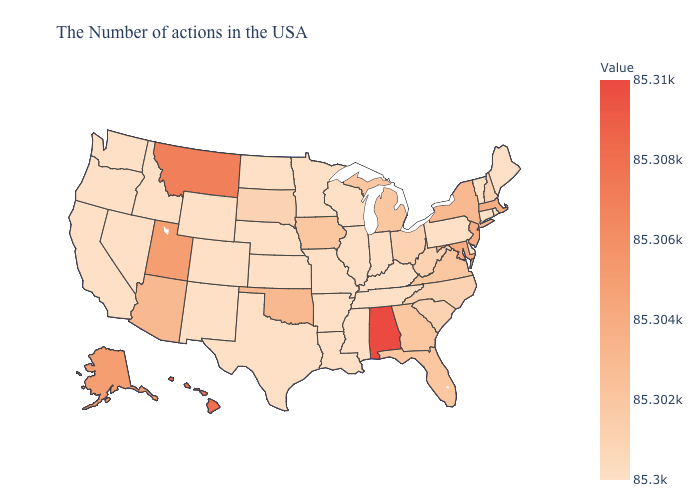Does the map have missing data?
Keep it brief. No. Is the legend a continuous bar?
Give a very brief answer. Yes. Is the legend a continuous bar?
Answer briefly. Yes. 